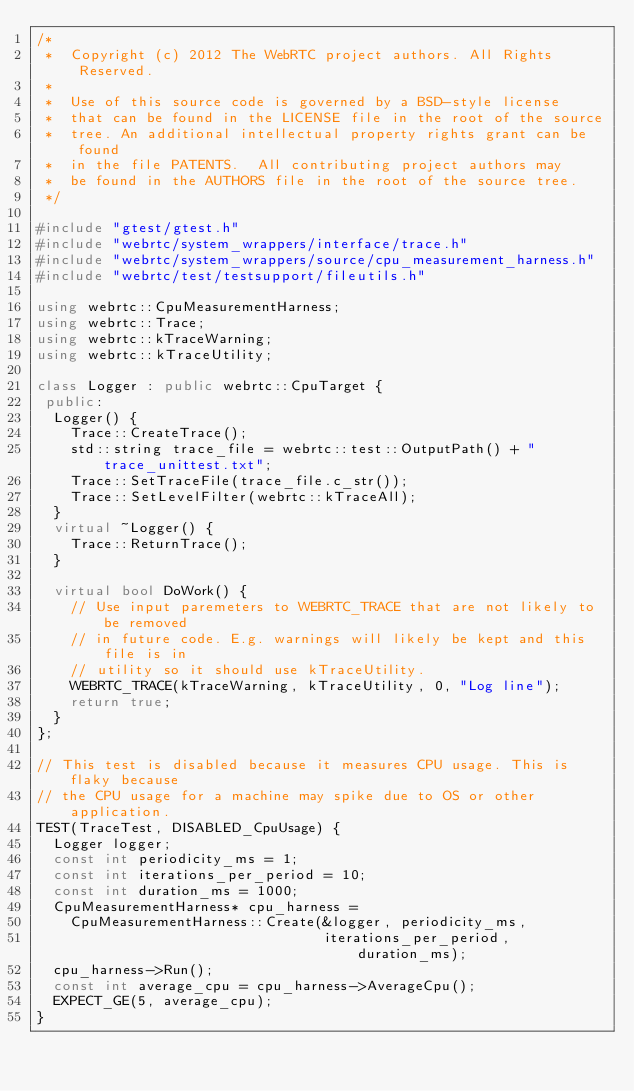Convert code to text. <code><loc_0><loc_0><loc_500><loc_500><_C++_>/*
 *  Copyright (c) 2012 The WebRTC project authors. All Rights Reserved.
 *
 *  Use of this source code is governed by a BSD-style license
 *  that can be found in the LICENSE file in the root of the source
 *  tree. An additional intellectual property rights grant can be found
 *  in the file PATENTS.  All contributing project authors may
 *  be found in the AUTHORS file in the root of the source tree.
 */

#include "gtest/gtest.h"
#include "webrtc/system_wrappers/interface/trace.h"
#include "webrtc/system_wrappers/source/cpu_measurement_harness.h"
#include "webrtc/test/testsupport/fileutils.h"

using webrtc::CpuMeasurementHarness;
using webrtc::Trace;
using webrtc::kTraceWarning;
using webrtc::kTraceUtility;

class Logger : public webrtc::CpuTarget {
 public:
  Logger() {
    Trace::CreateTrace();
    std::string trace_file = webrtc::test::OutputPath() + "trace_unittest.txt";
    Trace::SetTraceFile(trace_file.c_str());
    Trace::SetLevelFilter(webrtc::kTraceAll);
  }
  virtual ~Logger() {
    Trace::ReturnTrace();
  }

  virtual bool DoWork() {
    // Use input paremeters to WEBRTC_TRACE that are not likely to be removed
    // in future code. E.g. warnings will likely be kept and this file is in
    // utility so it should use kTraceUtility.
    WEBRTC_TRACE(kTraceWarning, kTraceUtility, 0, "Log line");
    return true;
  }
};

// This test is disabled because it measures CPU usage. This is flaky because
// the CPU usage for a machine may spike due to OS or other application.
TEST(TraceTest, DISABLED_CpuUsage) {
  Logger logger;
  const int periodicity_ms = 1;
  const int iterations_per_period = 10;
  const int duration_ms = 1000;
  CpuMeasurementHarness* cpu_harness =
    CpuMeasurementHarness::Create(&logger, periodicity_ms,
                                  iterations_per_period, duration_ms);
  cpu_harness->Run();
  const int average_cpu = cpu_harness->AverageCpu();
  EXPECT_GE(5, average_cpu);
}
</code> 